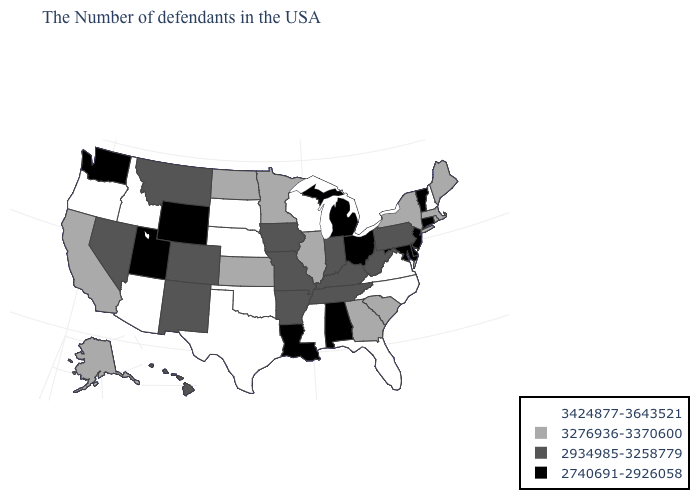What is the value of Arkansas?
Short answer required. 2934985-3258779. What is the value of Ohio?
Be succinct. 2740691-2926058. Name the states that have a value in the range 2740691-2926058?
Write a very short answer. Vermont, Connecticut, New Jersey, Delaware, Maryland, Ohio, Michigan, Alabama, Louisiana, Wyoming, Utah, Washington. What is the highest value in states that border Louisiana?
Quick response, please. 3424877-3643521. Does New York have the lowest value in the USA?
Concise answer only. No. Among the states that border Tennessee , which have the highest value?
Quick response, please. Virginia, North Carolina, Mississippi. Name the states that have a value in the range 3424877-3643521?
Give a very brief answer. New Hampshire, Virginia, North Carolina, Florida, Wisconsin, Mississippi, Nebraska, Oklahoma, Texas, South Dakota, Arizona, Idaho, Oregon. What is the value of Florida?
Write a very short answer. 3424877-3643521. Name the states that have a value in the range 3276936-3370600?
Keep it brief. Maine, Massachusetts, Rhode Island, New York, South Carolina, Georgia, Illinois, Minnesota, Kansas, North Dakota, California, Alaska. Does the first symbol in the legend represent the smallest category?
Quick response, please. No. Name the states that have a value in the range 3424877-3643521?
Short answer required. New Hampshire, Virginia, North Carolina, Florida, Wisconsin, Mississippi, Nebraska, Oklahoma, Texas, South Dakota, Arizona, Idaho, Oregon. Among the states that border Rhode Island , does Connecticut have the lowest value?
Be succinct. Yes. Name the states that have a value in the range 3276936-3370600?
Concise answer only. Maine, Massachusetts, Rhode Island, New York, South Carolina, Georgia, Illinois, Minnesota, Kansas, North Dakota, California, Alaska. Which states have the highest value in the USA?
Give a very brief answer. New Hampshire, Virginia, North Carolina, Florida, Wisconsin, Mississippi, Nebraska, Oklahoma, Texas, South Dakota, Arizona, Idaho, Oregon. Among the states that border New York , does New Jersey have the lowest value?
Short answer required. Yes. 